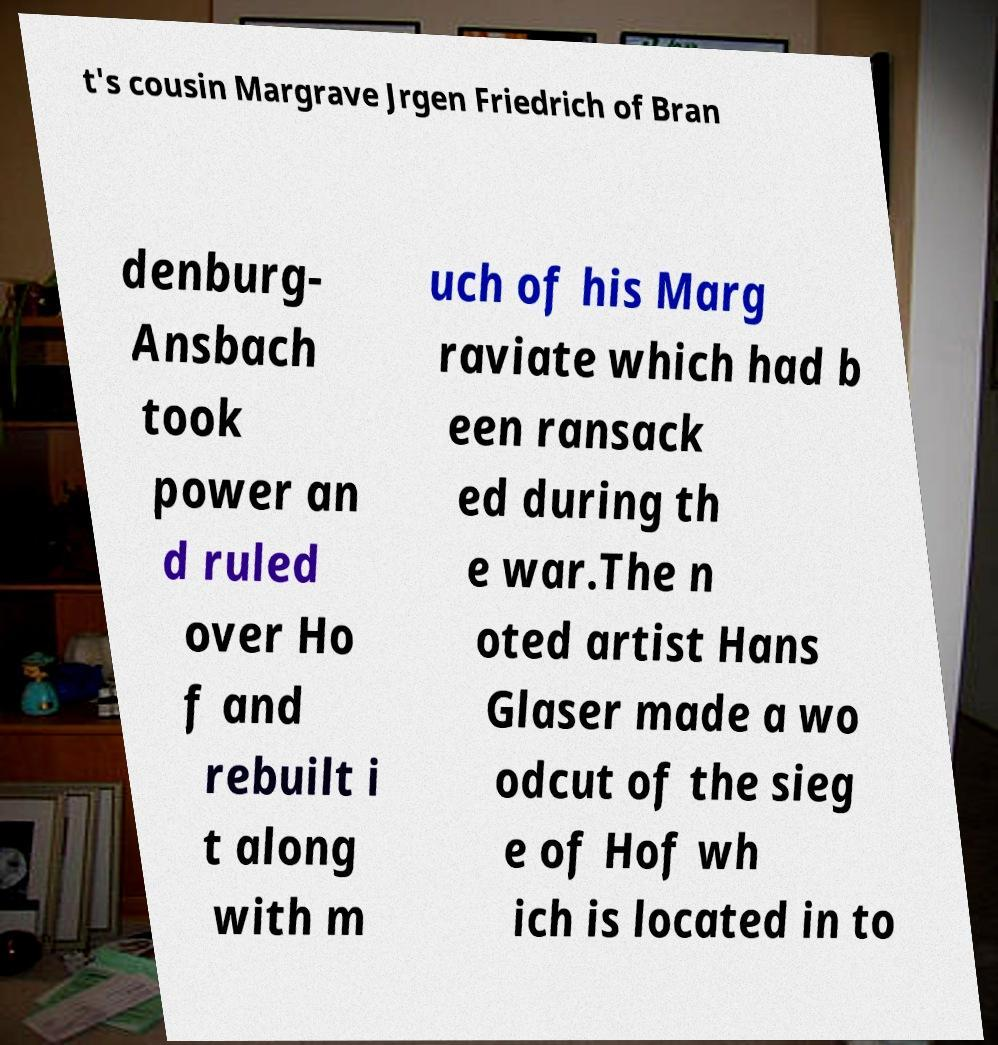Could you extract and type out the text from this image? t's cousin Margrave Jrgen Friedrich of Bran denburg- Ansbach took power an d ruled over Ho f and rebuilt i t along with m uch of his Marg raviate which had b een ransack ed during th e war.The n oted artist Hans Glaser made a wo odcut of the sieg e of Hof wh ich is located in to 